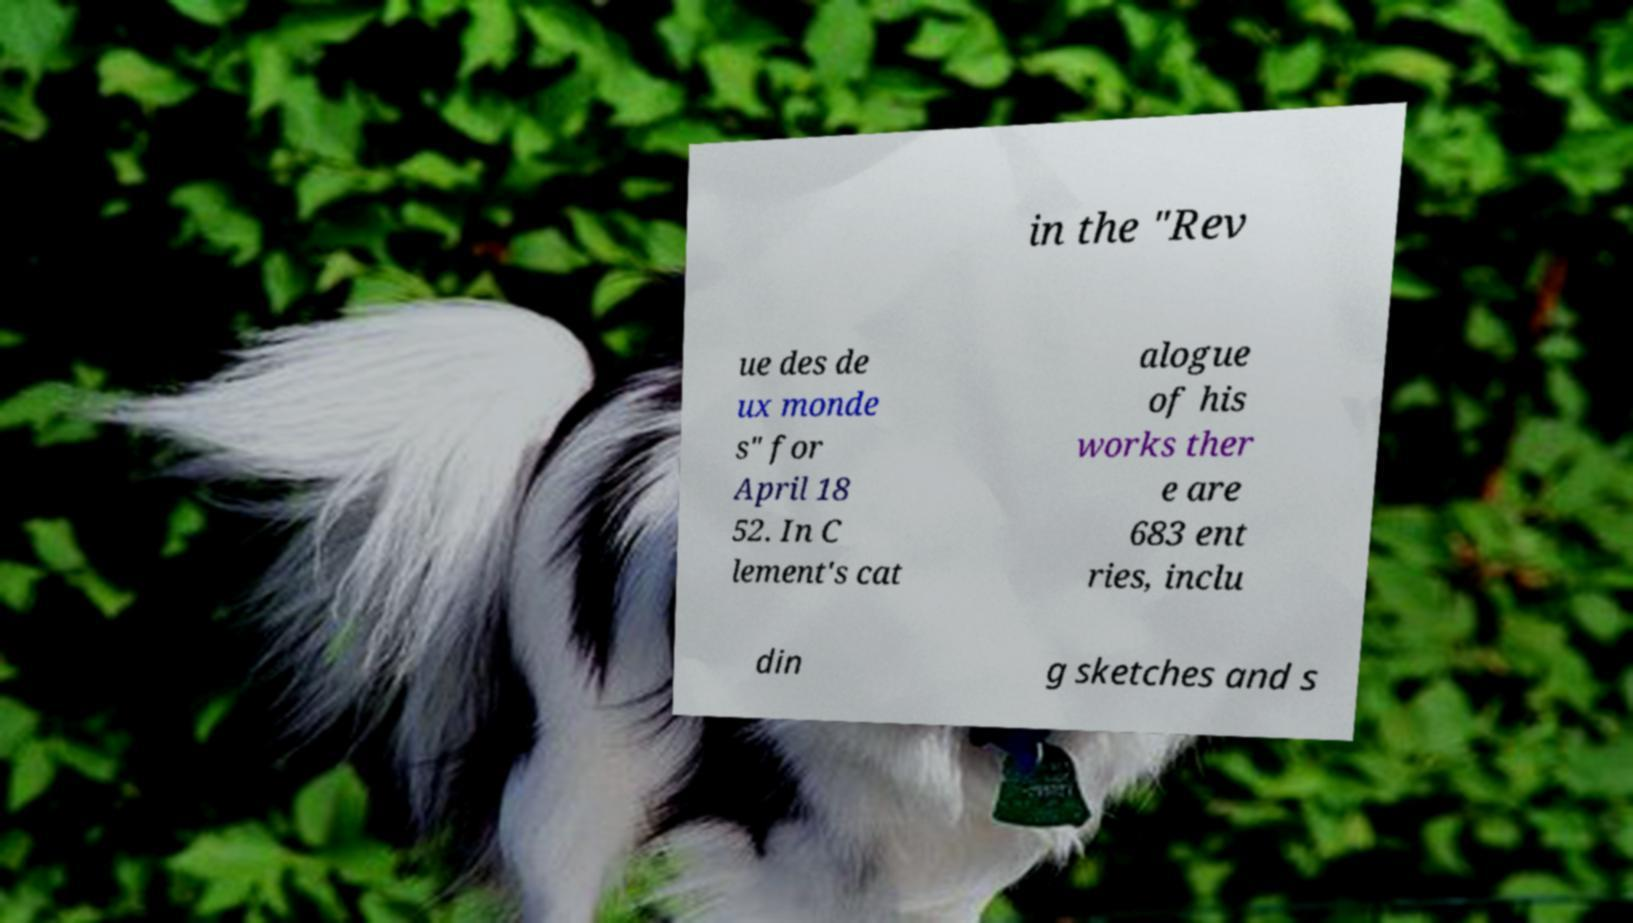Please read and relay the text visible in this image. What does it say? in the "Rev ue des de ux monde s" for April 18 52. In C lement's cat alogue of his works ther e are 683 ent ries, inclu din g sketches and s 